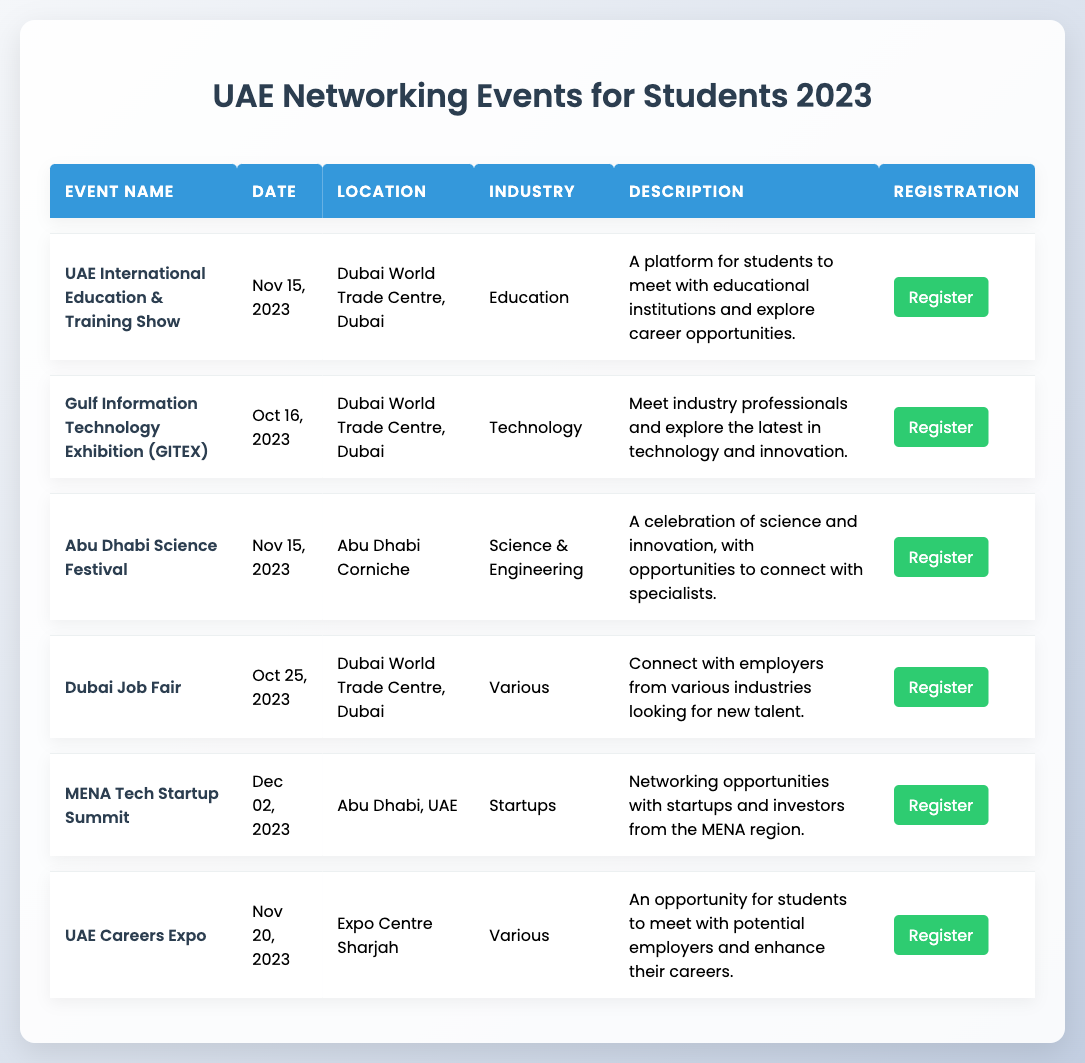What is the date of the Gulf Information Technology Exhibition? The table lists the Gulf Information Technology Exhibition with a date specified as October 16, 2023.
Answer: October 16, 2023 Which industry does the UAE International Education & Training Show belong to? Referring to the industry column of the table, the UAE International Education & Training Show is categorized under "Education".
Answer: Education How many events are taking place on November 15, 2023? By checking the table for the date column, I see two events: UAE International Education & Training Show and Abu Dhabi Science Festival are both scheduled for that date. Thus, the count is 2.
Answer: 2 Is the Dubai Job Fair focused on a specific industry? The description in the industry column indicates that the Dubai Job Fair is listed under "Various," meaning it does not focus on any one specific industry.
Answer: No Which event has the latest date according to the table? Analyzing the date column, the MENA Tech Startup Summit falls on December 2, 2023, which is later than the dates of all other listed events.
Answer: December 2, 2023 What is the main purpose of the UAE Careers Expo? The description states that the UAE Careers Expo offers students a chance to meet potential employers and enhance their careers, making networking a central focus of the event.
Answer: To network with potential employers How many different locations are mentioned in the table? By reviewing the location column, I identify three unique locations: Dubai World Trade Centre, Abu Dhabi Corniche, and Expo Centre Sharjah, resulting in a total of three distinct locations.
Answer: 3 Does the MENA Tech Startup Summit occur before the UAE International Education & Training Show? Comparing the dates of these events, the MENA Tech Startup Summit is on December 2, 2023, while the UAE International Education & Training Show is on November 15, 2023. Therefore, the MENA Tech Summit occurs after the UAE International Education & Training Show.
Answer: No What is the registration link for the Abu Dhabi Science Festival? The table lists the registration link for the Abu Dhabi Science Festival as https://www.adscifestival.com, indicating where to sign up for this event.
Answer: https://www.adscifestival.com 